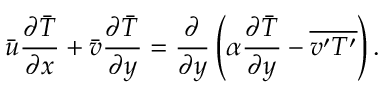Convert formula to latex. <formula><loc_0><loc_0><loc_500><loc_500>{ \bar { u } } { \frac { \partial { \bar { T } } } { \partial x } } + { \bar { v } } { \frac { \partial { \bar { T } } } { \partial y } } = { \frac { \partial } { \partial y } } \left ( \alpha { \frac { \partial { \bar { T } } } { \partial y } } - { \overline { { v ^ { \prime } T ^ { \prime } } } } \right ) .</formula> 